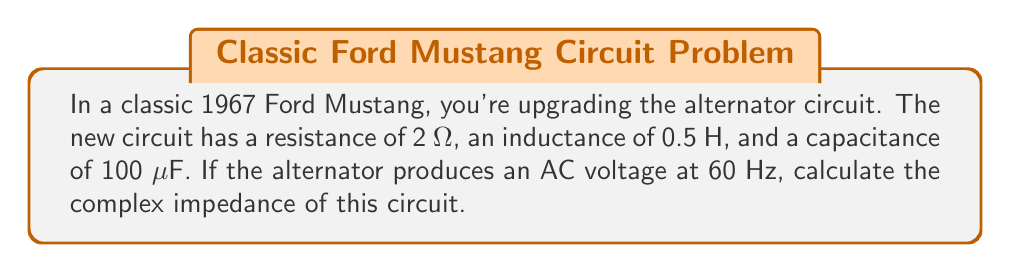Can you answer this question? To calculate the complex impedance of this AC circuit, we need to consider the resistance (R), inductive reactance ($X_L$), and capacitive reactance ($X_C$).

1. The resistance is given: $R = 2$ Ω

2. Calculate the inductive reactance:
   $X_L = 2\pi fL$
   where $f$ is the frequency and $L$ is the inductance
   $X_L = 2\pi(60)(0.5) = 188.5$ Ω

3. Calculate the capacitive reactance:
   $X_C = \frac{1}{2\pi fC}$
   where $C$ is the capacitance in Farads
   $C = 100 \mu F = 1 \times 10^{-4}$ F
   $X_C = \frac{1}{2\pi(60)(1 \times 10^{-4})} = 26.5$ Ω

4. The complex impedance is given by:
   $Z = R + j(X_L - X_C)$
   where $j$ is the imaginary unit

5. Substituting the values:
   $Z = 2 + j(188.5 - 26.5)$
   $Z = 2 + j(162)$

6. This can be written in polar form as:
   $Z = \sqrt{2^2 + 162^2} \angle \tan^{-1}(\frac{162}{2})$
   $Z = 162.02 \angle 89.29°$ Ω
Answer: $Z = 2 + j162$ Ω or $162.02 \angle 89.29°$ Ω 